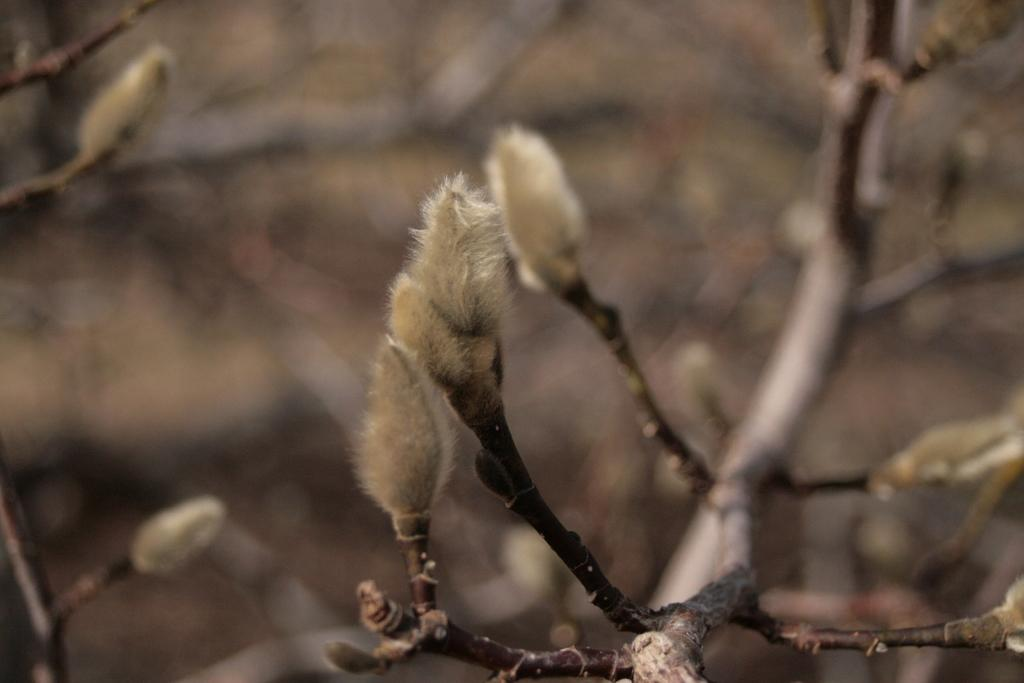What type of plant can be seen in the image? There is a plant with buds in the image. Can you describe the background of the image? The background of the image is blurred. How many chairs are visible in the image? There are no chairs present in the image. What type of property is shown in the image? There is no property shown in the image; it features a plant with buds against a blurred background. 